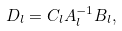Convert formula to latex. <formula><loc_0><loc_0><loc_500><loc_500>D _ { l } = C _ { l } A _ { l } ^ { - 1 } B _ { l } ,</formula> 